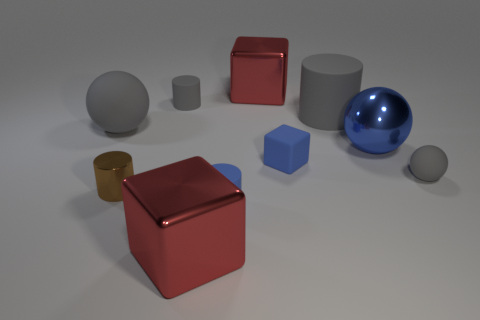Subtract all balls. How many objects are left? 7 Subtract all tiny gray metal cylinders. Subtract all gray spheres. How many objects are left? 8 Add 1 gray matte cylinders. How many gray matte cylinders are left? 3 Add 3 big cylinders. How many big cylinders exist? 4 Subtract 2 gray cylinders. How many objects are left? 8 